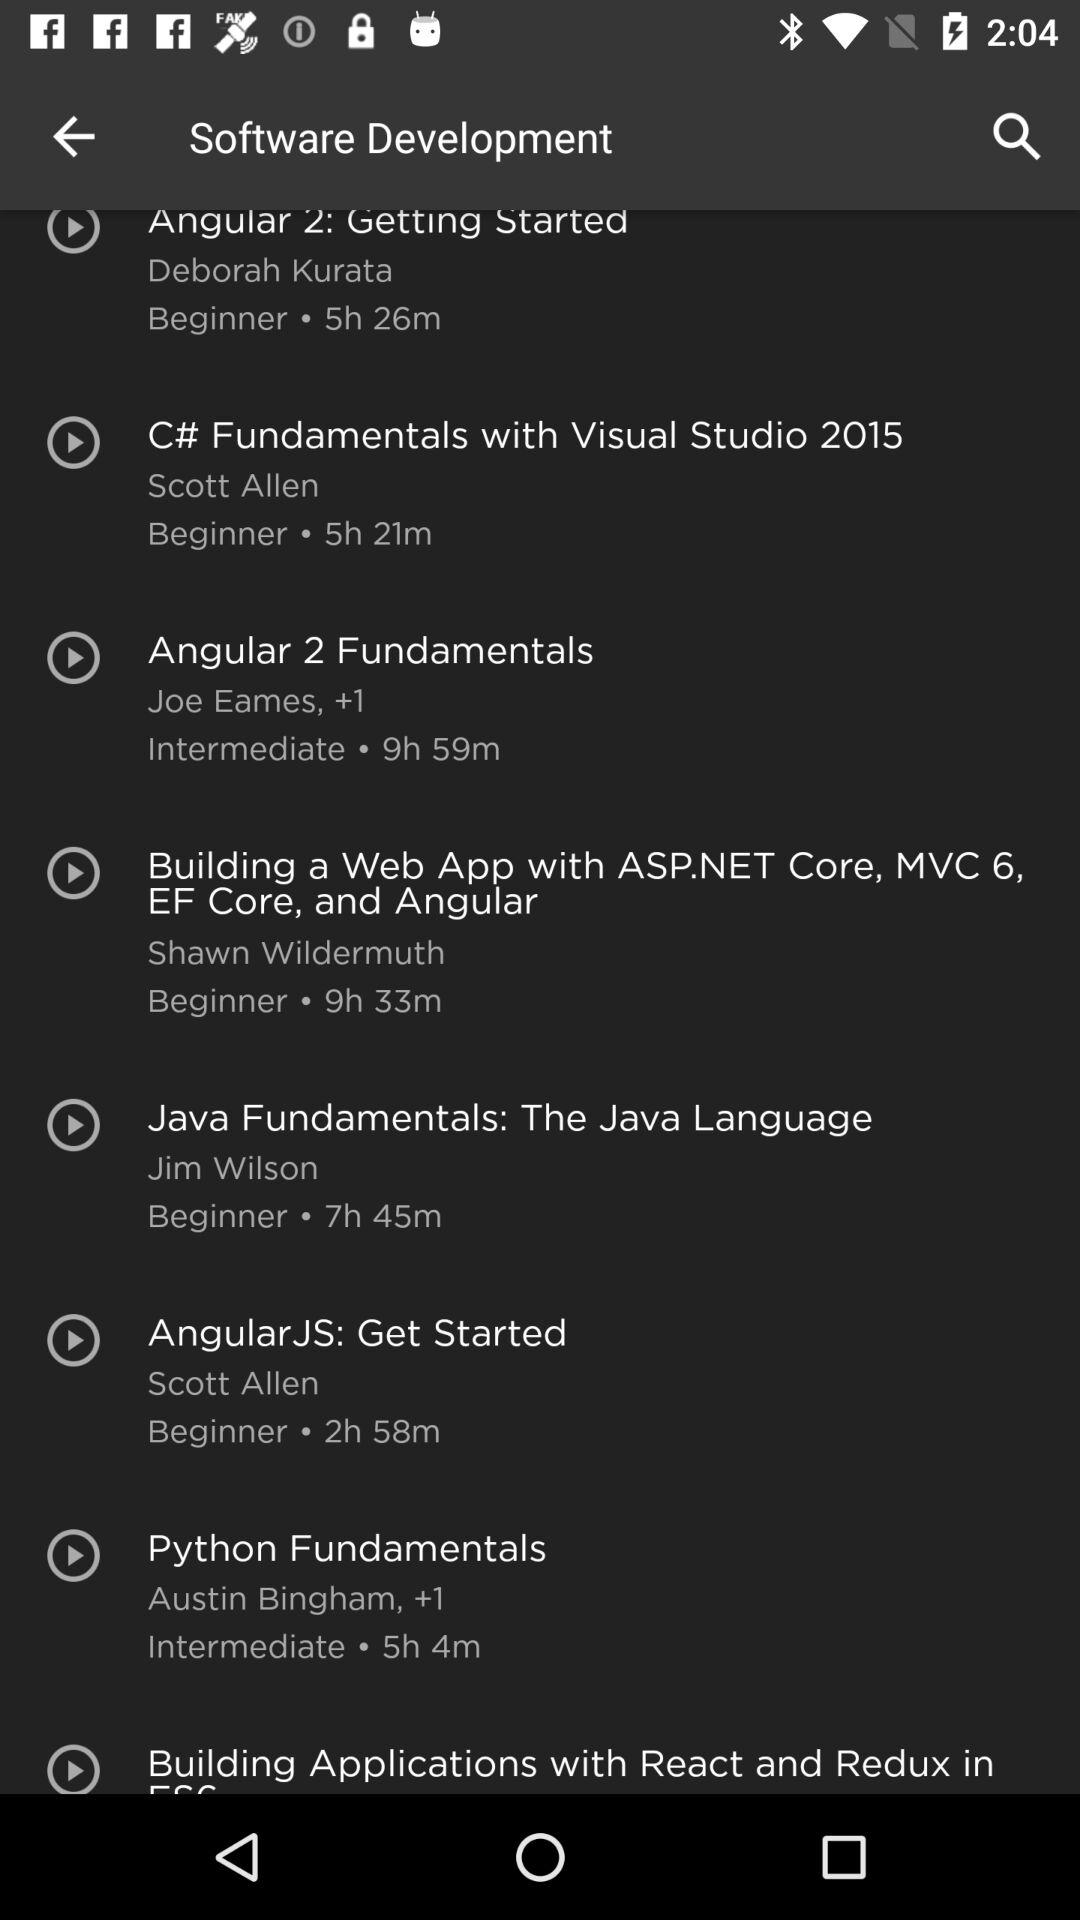Can you recommend a course for beginners interested in C#? Certainly! The course titled 'C# Fundamentals with Visual Studio 2015', taught by Scott Allen, is catered to beginners and lasts approximately 5 hours and 21 minutes. 